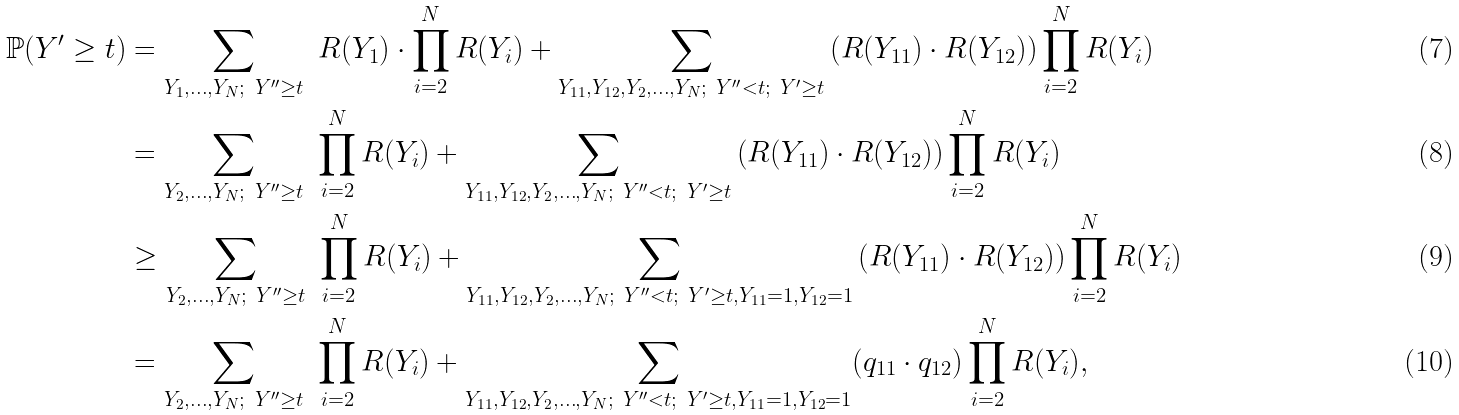Convert formula to latex. <formula><loc_0><loc_0><loc_500><loc_500>\mathbb { P } ( Y ^ { \prime } \geq t ) & = \sum _ { Y _ { 1 } , \dots , Y _ { N } ; \ Y ^ { \prime \prime } \geq t } \ R ( Y _ { 1 } ) \cdot \prod _ { i = 2 } ^ { N } R ( Y _ { i } ) + \sum _ { Y _ { 1 1 } , Y _ { 1 2 } , Y _ { 2 } , \dots , Y _ { N } ; \ Y ^ { \prime \prime } < t ; \ Y ^ { \prime } \geq t } \left ( R ( Y _ { 1 1 } ) \cdot R ( Y _ { 1 2 } ) \right ) \prod _ { i = 2 } ^ { N } R ( Y _ { i } ) \\ & = \sum _ { Y _ { 2 } , \dots , Y _ { N } ; \ Y ^ { \prime \prime } \geq t } \ \prod _ { i = 2 } ^ { N } R ( Y _ { i } ) + \sum _ { Y _ { 1 1 } , Y _ { 1 2 } , Y _ { 2 } , \dots , Y _ { N } ; \ Y ^ { \prime \prime } < t ; \ Y ^ { \prime } \geq t } \left ( R ( Y _ { 1 1 } ) \cdot R ( Y _ { 1 2 } ) \right ) \prod _ { i = 2 } ^ { N } R ( Y _ { i } ) \\ & \geq \sum _ { Y _ { 2 } , \dots , Y _ { N } ; \ Y ^ { \prime \prime } \geq t } \ \prod _ { i = 2 } ^ { N } R ( Y _ { i } ) + \sum _ { Y _ { 1 1 } , Y _ { 1 2 } , Y _ { 2 } , \dots , Y _ { N } ; \ Y ^ { \prime \prime } < t ; \ Y ^ { \prime } \geq t , Y _ { 1 1 } = 1 , Y _ { 1 2 } = 1 } \left ( R ( Y _ { 1 1 } ) \cdot R ( Y _ { 1 2 } ) \right ) \prod _ { i = 2 } ^ { N } R ( Y _ { i } ) \\ & = \sum _ { Y _ { 2 } , \dots , Y _ { N } ; \ Y ^ { \prime \prime } \geq t } \ \prod _ { i = 2 } ^ { N } R ( Y _ { i } ) + \sum _ { Y _ { 1 1 } , Y _ { 1 2 } , Y _ { 2 } , \dots , Y _ { N } ; \ Y ^ { \prime \prime } < t ; \ Y ^ { \prime } \geq t , Y _ { 1 1 } = 1 , Y _ { 1 2 } = 1 } ( q _ { 1 1 } \cdot q _ { 1 2 } ) \prod _ { i = 2 } ^ { N } R ( Y _ { i } ) ,</formula> 